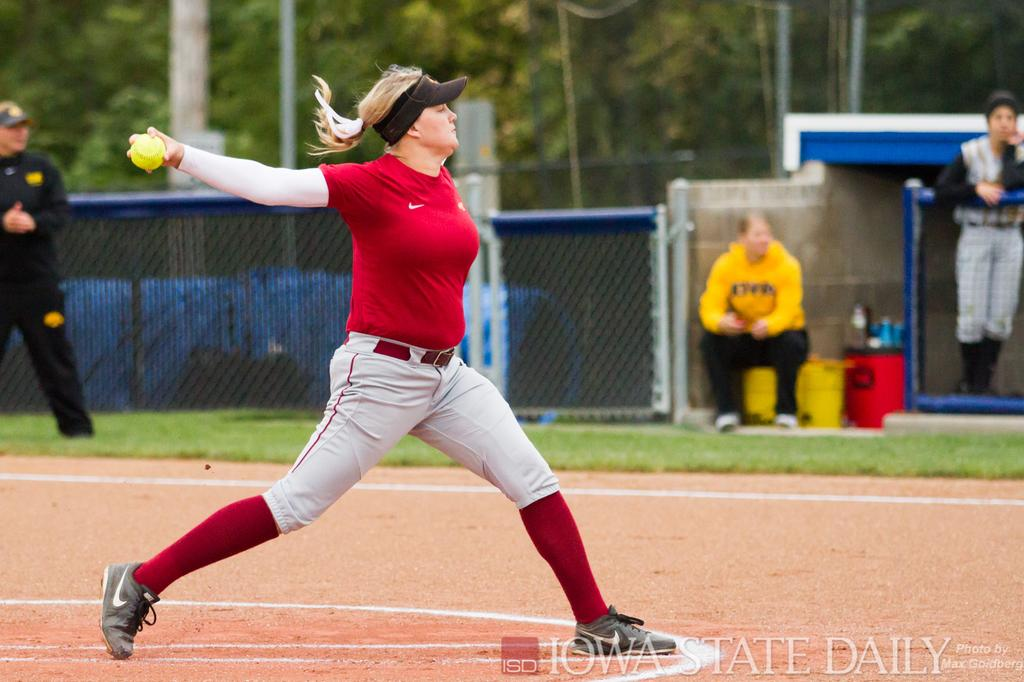<image>
Render a clear and concise summary of the photo. a female pitcher throwing a ball, the photo taken by iowa state daily 